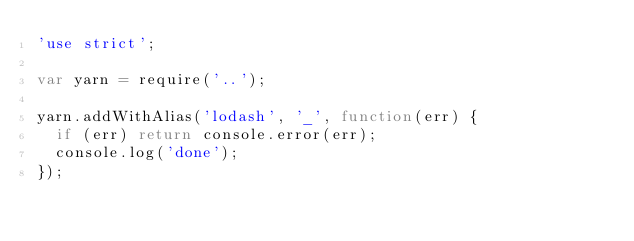<code> <loc_0><loc_0><loc_500><loc_500><_JavaScript_>'use strict';

var yarn = require('..');

yarn.addWithAlias('lodash', '_', function(err) {
  if (err) return console.error(err);
  console.log('done');
});
</code> 